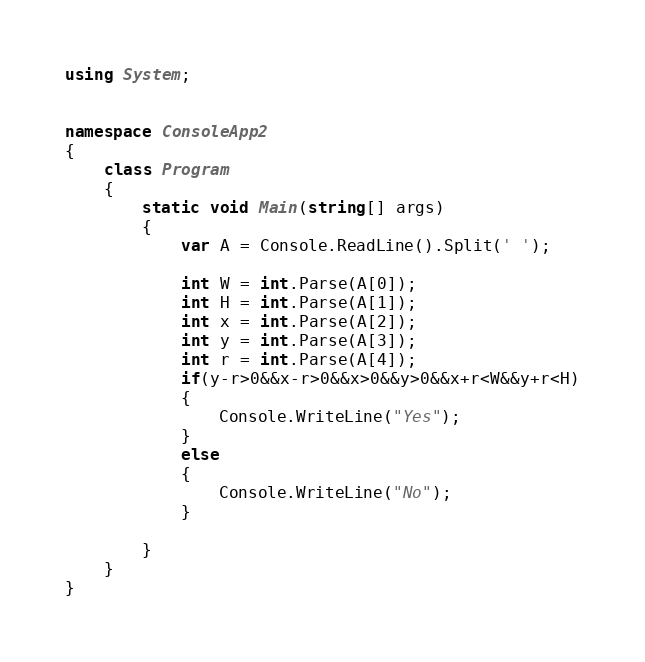Convert code to text. <code><loc_0><loc_0><loc_500><loc_500><_C#_>using System;


namespace ConsoleApp2
{
    class Program
    {
        static void Main(string[] args)
        {
            var A = Console.ReadLine().Split(' ');
           
            int W = int.Parse(A[0]);
            int H = int.Parse(A[1]);
            int x = int.Parse(A[2]);
            int y = int.Parse(A[3]);
            int r = int.Parse(A[4]);
            if(y-r>0&&x-r>0&&x>0&&y>0&&x+r<W&&y+r<H)
            {
                Console.WriteLine("Yes");
            }
            else
            {
                Console.WriteLine("No");
            }
            
        }
    }
}</code> 